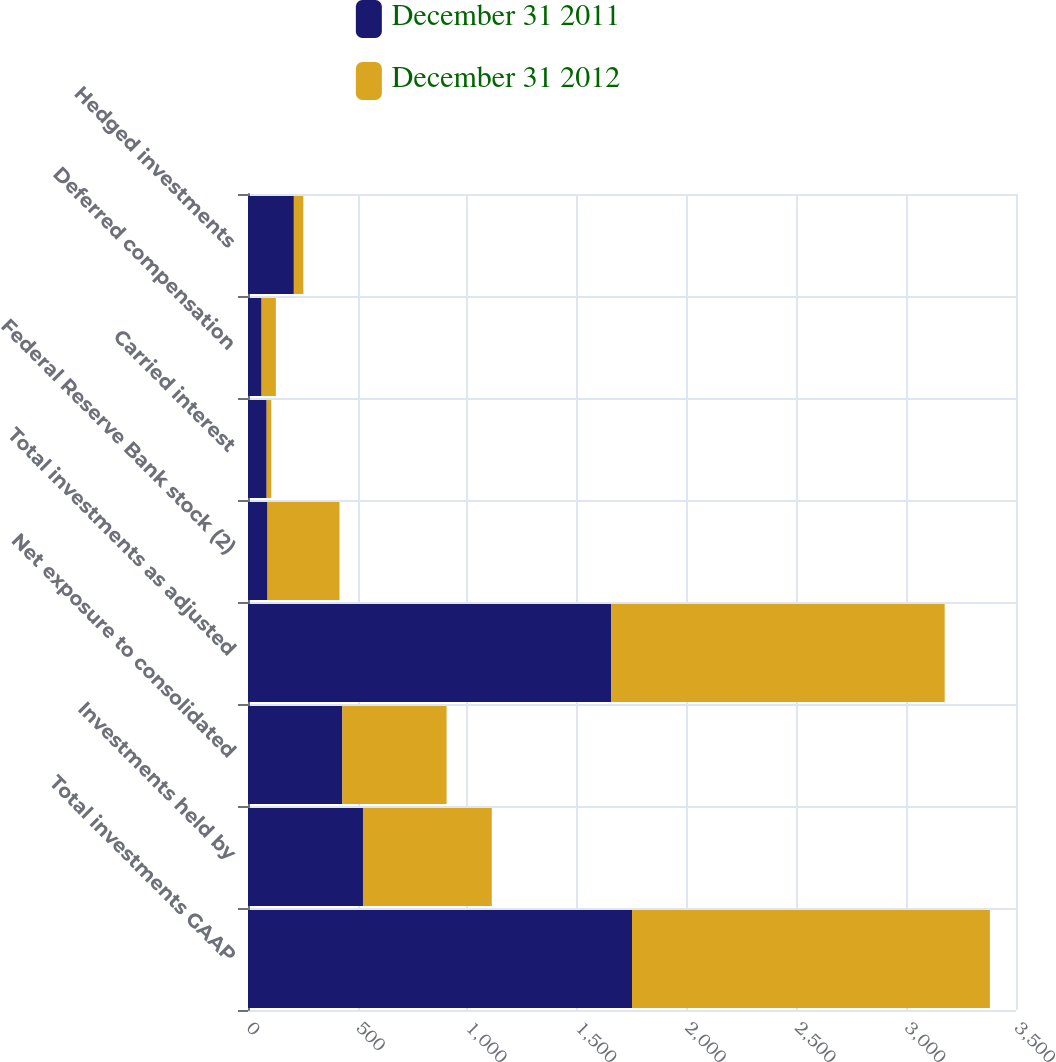<chart> <loc_0><loc_0><loc_500><loc_500><stacked_bar_chart><ecel><fcel>Total investments GAAP<fcel>Investments held by<fcel>Net exposure to consolidated<fcel>Total investments as adjusted<fcel>Federal Reserve Bank stock (2)<fcel>Carried interest<fcel>Deferred compensation<fcel>Hedged investments<nl><fcel>December 31 2011<fcel>1750<fcel>524<fcel>430<fcel>1656<fcel>89<fcel>85<fcel>62<fcel>209<nl><fcel>December 31 2012<fcel>1631<fcel>587<fcel>475<fcel>1519<fcel>328<fcel>21<fcel>65<fcel>43<nl></chart> 